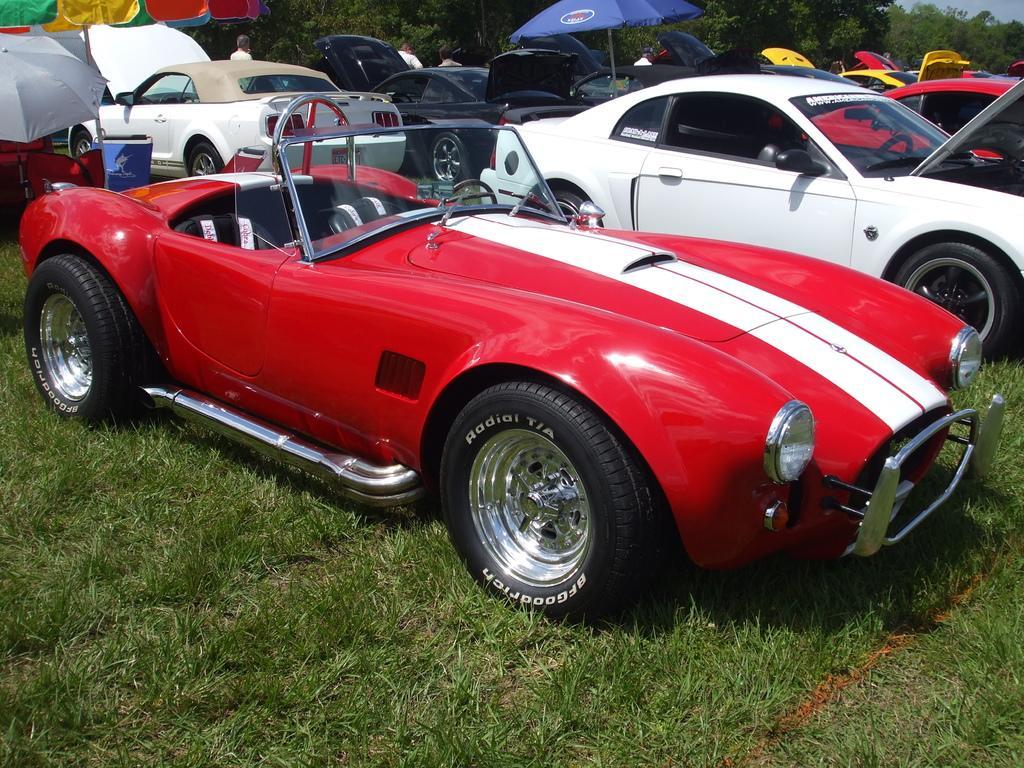Could you give a brief overview of what you see in this image? In this image I can see few vehicles. In front the vehicle is in white and red color. In the background I can see few people standing, an umbrella in blue color and few trees in green color. 